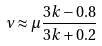<formula> <loc_0><loc_0><loc_500><loc_500>\nu \approx \mu \frac { 3 k - 0 . 8 } { 3 k + 0 . 2 }</formula> 